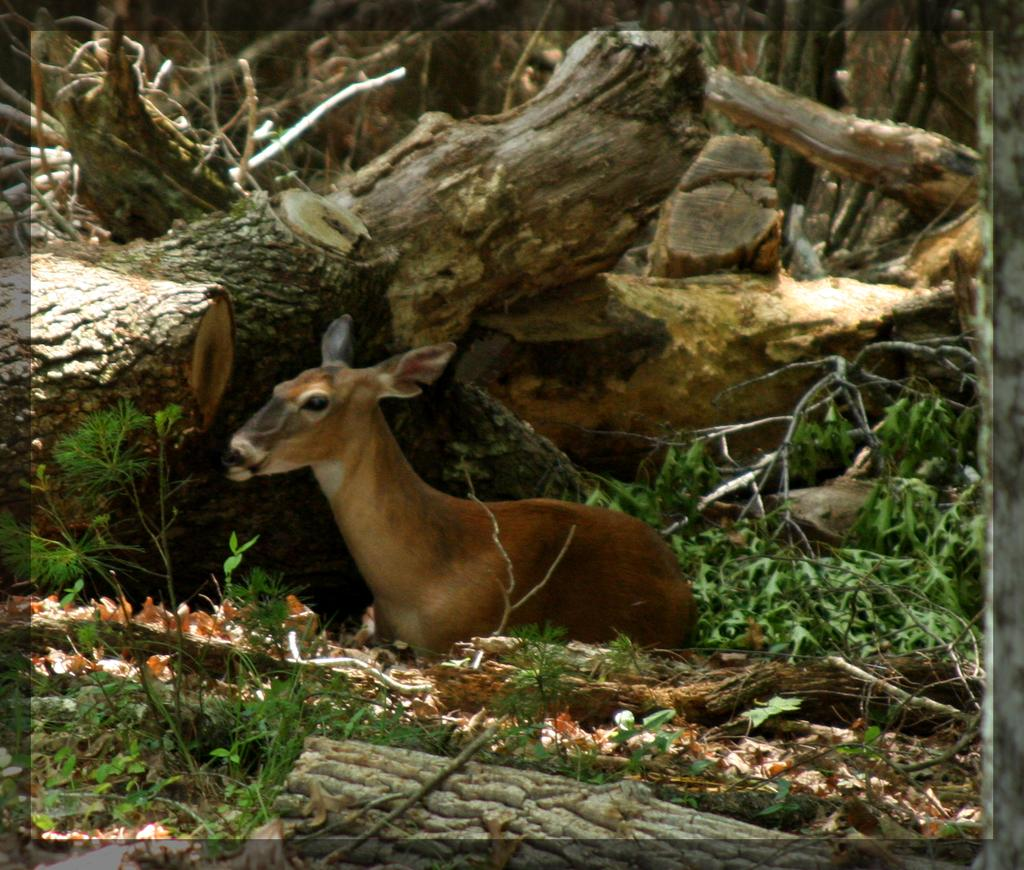What type of living organisms can be seen in the image? Plants and an animal can be seen in the image. What type of natural environment is visible in the image? Woods are visible in the image. Can you describe the animal in the image? The animal is located in the middle of the image. What type of joke is the animal telling in the image? There is no indication in the image that the animal is telling a joke, as animals do not have the ability to tell jokes. 